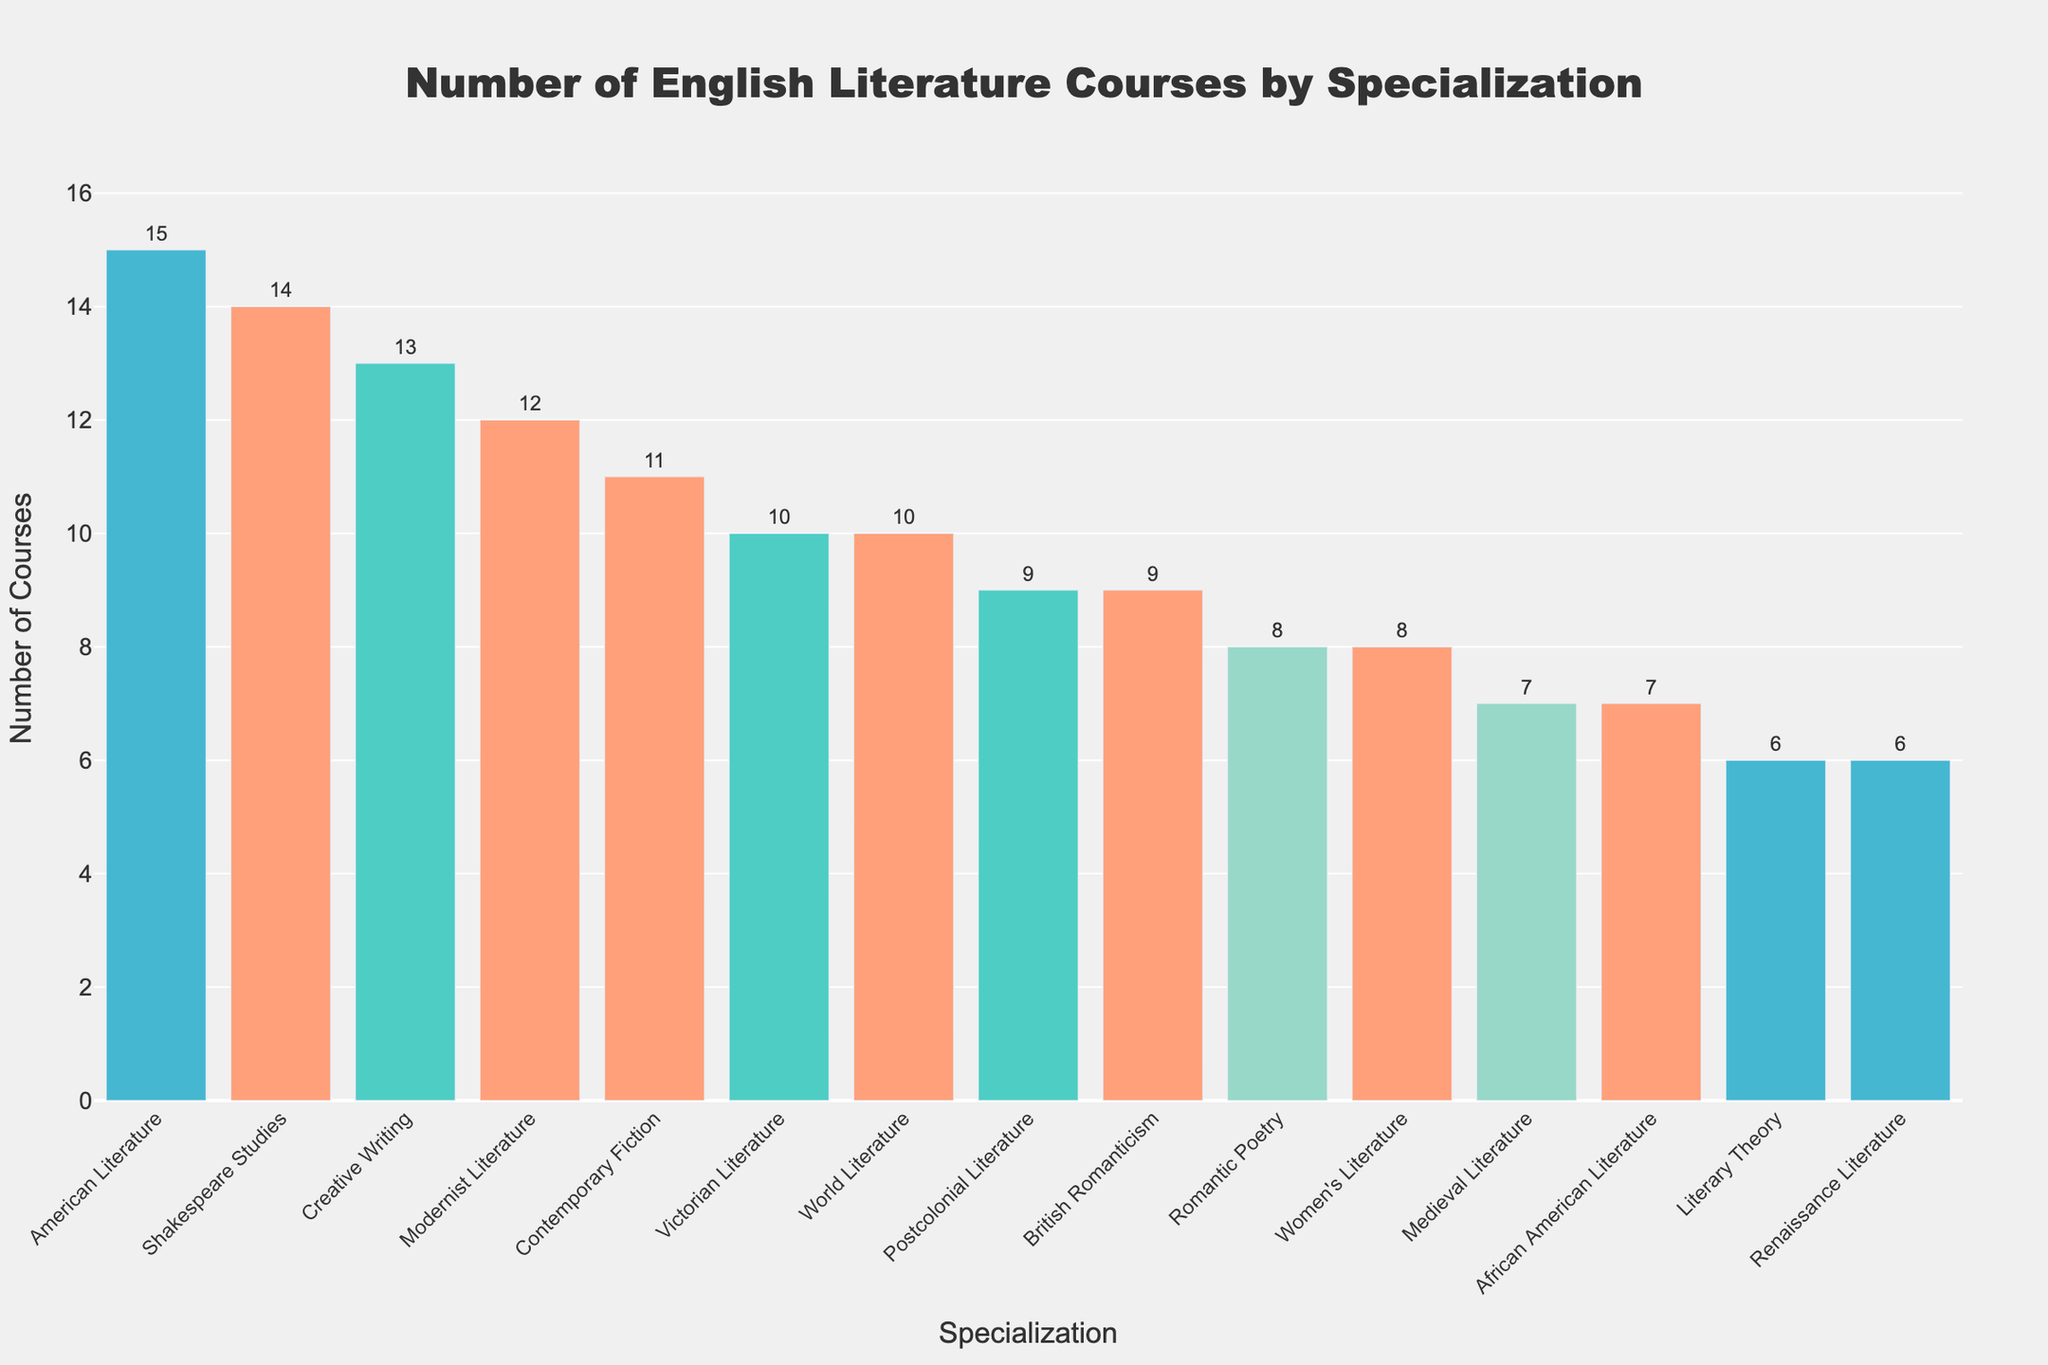Which specialization has the highest number of courses? To identify this, look for the tallest bar in the figure and read its corresponding specialization and number of courses.
Answer: American Literature How many specializations have more than 10 courses? Count the bars that extend above the line indicating 10 courses. These represent the specializations that have more than 10 courses.
Answer: 5 What is the total number of courses offered in both Contemporary Fiction and Postcolonial Literature? Locate the bars for Contemporary Fiction and Postcolonial Literature, read their corresponding course numbers (11 and 9), and add these values together: 11 + 9 = 20.
Answer: 20 Which specialization has fewer courses, Medieval Literature or Women's Literature? Compare the heights of the bars for Medieval Literature and Women's Literature. Medieval Literature has 7 courses, while Women's Literature has 8 courses. Thus, Medieval Literature has fewer courses.
Answer: Medieval Literature What is the average number of courses offered in Romantic Poetry, Literary Theory, and Renaissance Literature? Find the course numbers for these specializations (8, 6, and 6), sum them up: 8 + 6 + 6 = 20, and calculate the average by dividing the total by 3: 20 ÷ 3 ≈ 6.67.
Answer: 6.67 What is the difference in the number of courses between Shakespeare Studies and Victorian Literature? Read the course numbers for Shakespeare Studies (14) and Victorian Literature (10), and subtract the latter from the former: 14 - 10 = 4.
Answer: 4 Which specialization has a bar colored blue? Identify the bar colored blue and read the specialization it corresponds to in the chart. Note that the question requires referring to colors assigned in the visual.
Answer: Creative Writing (if assumed) Are there any specializations with exactly 7 courses, and if so, which ones? Look for bars that reach exactly the line marking 7 and read their corresponding specializations.
Answer: Medieval Literature, African American Literature Which specialization is ranked third in the number of courses offered? The third tallest bar from the sorted chart indicates the specialization with the third highest number of courses.
Answer: Creative Writing How many more courses are offered in Women's Literature compared to Literary Theory? Read the course numbers for Women's Literature (8) and Literary Theory (6) from the chart, then subtract the number of Literary Theory courses from Women's Literature ones: 8 - 6 = 2.
Answer: 2 